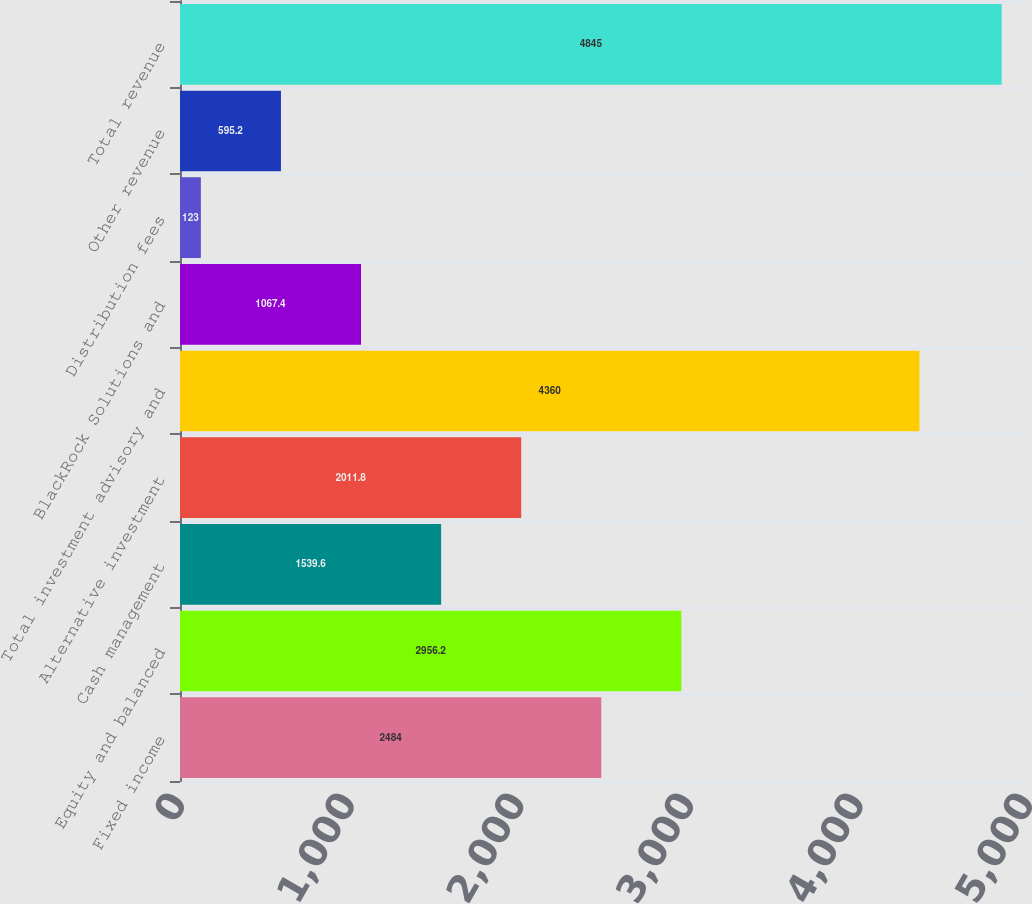Convert chart to OTSL. <chart><loc_0><loc_0><loc_500><loc_500><bar_chart><fcel>Fixed income<fcel>Equity and balanced<fcel>Cash management<fcel>Alternative investment<fcel>Total investment advisory and<fcel>BlackRock Solutions and<fcel>Distribution fees<fcel>Other revenue<fcel>Total revenue<nl><fcel>2484<fcel>2956.2<fcel>1539.6<fcel>2011.8<fcel>4360<fcel>1067.4<fcel>123<fcel>595.2<fcel>4845<nl></chart> 